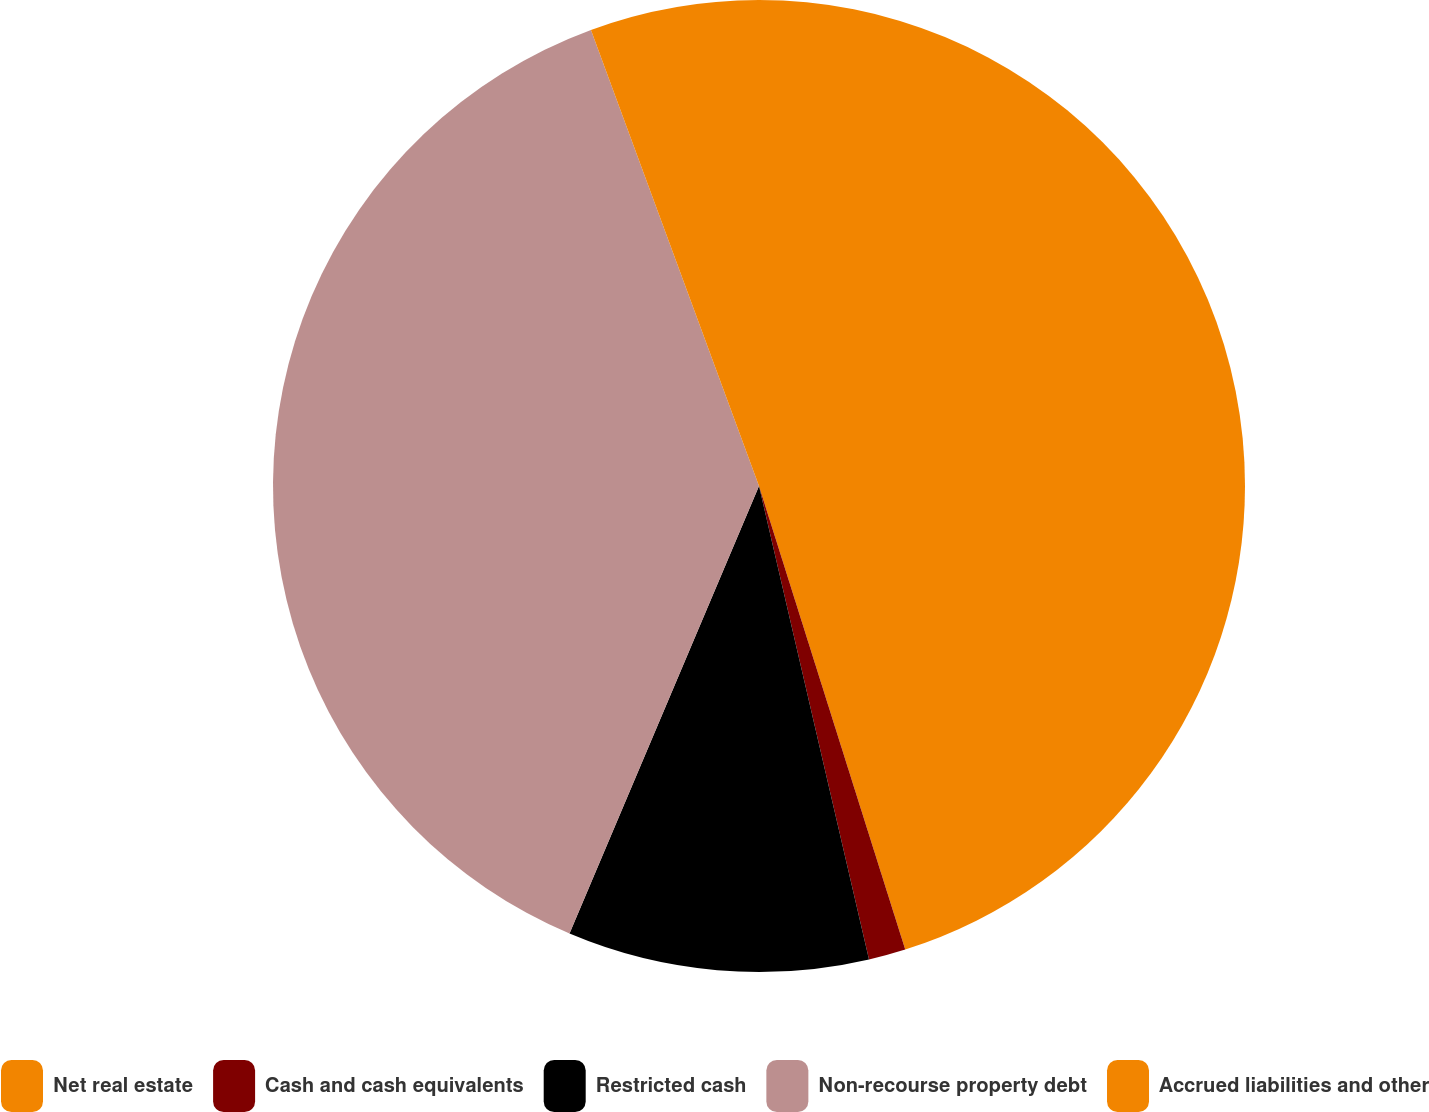Convert chart to OTSL. <chart><loc_0><loc_0><loc_500><loc_500><pie_chart><fcel>Net real estate<fcel>Cash and cash equivalents<fcel>Restricted cash<fcel>Non-recourse property debt<fcel>Accrued liabilities and other<nl><fcel>45.14%<fcel>1.23%<fcel>10.01%<fcel>38.01%<fcel>5.62%<nl></chart> 